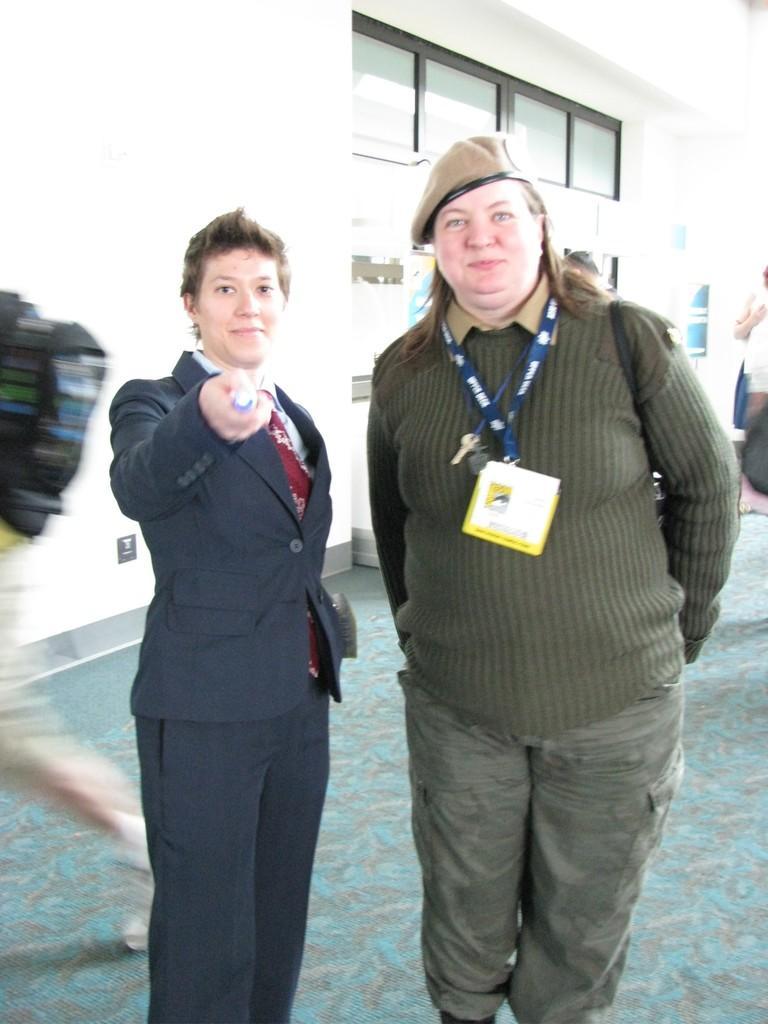In one or two sentences, can you explain what this image depicts? In this image we can see some people standing. One woman is holding an object in her hand. On the left side of the image we a person wearing bag and walking. In the background, we can see some windows and a board with some text. 